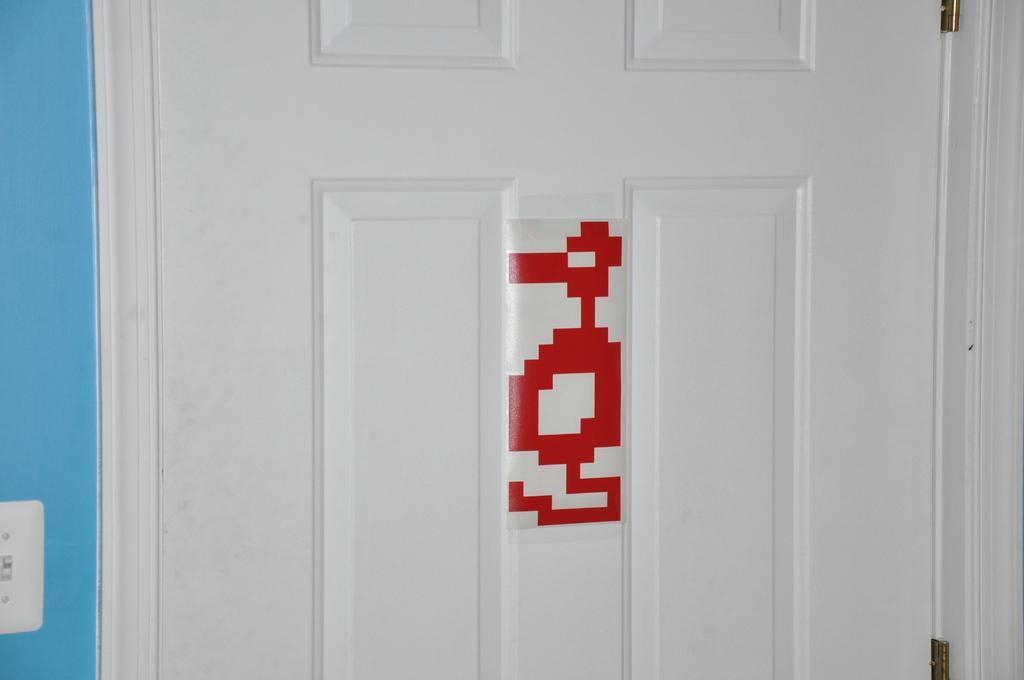Describe this image in one or two sentences. In the image we can see a door, white in color. On the door there is a design, red in color. Here we can even see a wall, blue in color. 